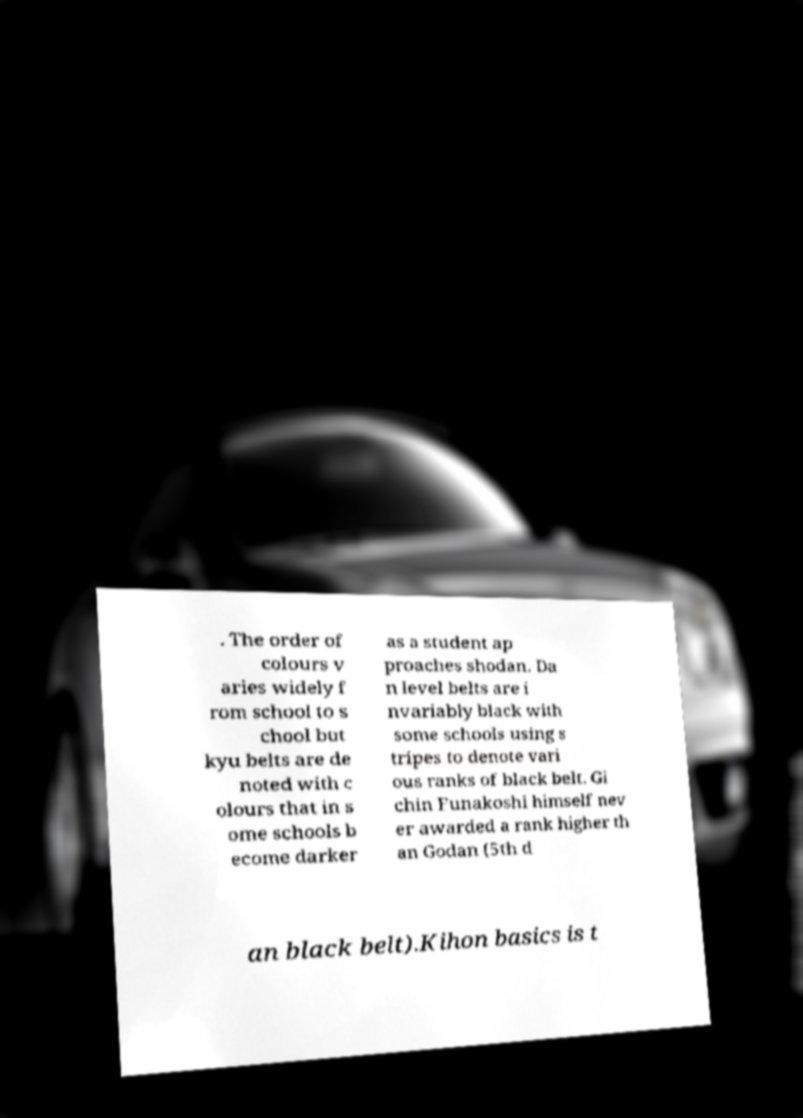What messages or text are displayed in this image? I need them in a readable, typed format. . The order of colours v aries widely f rom school to s chool but kyu belts are de noted with c olours that in s ome schools b ecome darker as a student ap proaches shodan. Da n level belts are i nvariably black with some schools using s tripes to denote vari ous ranks of black belt. Gi chin Funakoshi himself nev er awarded a rank higher th an Godan (5th d an black belt).Kihon basics is t 